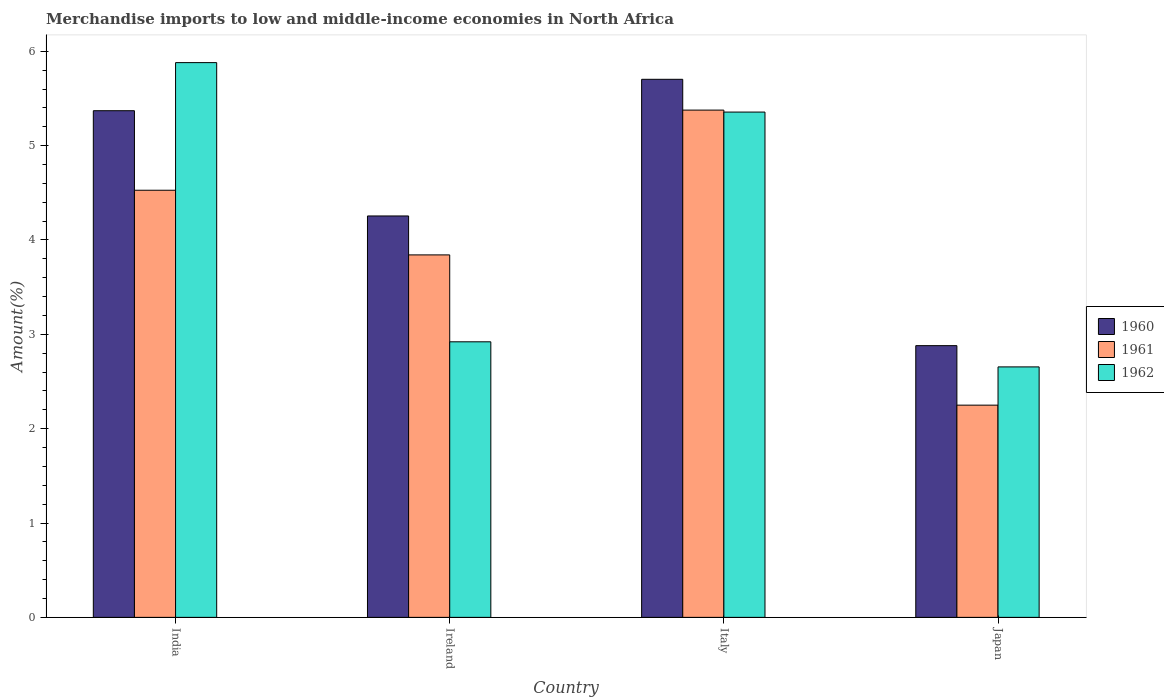Are the number of bars on each tick of the X-axis equal?
Ensure brevity in your answer.  Yes. How many bars are there on the 1st tick from the right?
Provide a succinct answer. 3. What is the percentage of amount earned from merchandise imports in 1962 in Ireland?
Ensure brevity in your answer.  2.92. Across all countries, what is the maximum percentage of amount earned from merchandise imports in 1960?
Keep it short and to the point. 5.7. Across all countries, what is the minimum percentage of amount earned from merchandise imports in 1962?
Offer a terse response. 2.65. In which country was the percentage of amount earned from merchandise imports in 1962 minimum?
Provide a short and direct response. Japan. What is the total percentage of amount earned from merchandise imports in 1961 in the graph?
Your answer should be compact. 16. What is the difference between the percentage of amount earned from merchandise imports in 1962 in Ireland and that in Japan?
Your answer should be very brief. 0.27. What is the difference between the percentage of amount earned from merchandise imports in 1961 in Italy and the percentage of amount earned from merchandise imports in 1962 in India?
Provide a short and direct response. -0.5. What is the average percentage of amount earned from merchandise imports in 1962 per country?
Provide a short and direct response. 4.2. What is the difference between the percentage of amount earned from merchandise imports of/in 1961 and percentage of amount earned from merchandise imports of/in 1960 in Japan?
Keep it short and to the point. -0.63. In how many countries, is the percentage of amount earned from merchandise imports in 1960 greater than 1.4 %?
Provide a short and direct response. 4. What is the ratio of the percentage of amount earned from merchandise imports in 1961 in Italy to that in Japan?
Your answer should be very brief. 2.39. Is the difference between the percentage of amount earned from merchandise imports in 1961 in Ireland and Italy greater than the difference between the percentage of amount earned from merchandise imports in 1960 in Ireland and Italy?
Offer a terse response. No. What is the difference between the highest and the second highest percentage of amount earned from merchandise imports in 1960?
Provide a succinct answer. 1.12. What is the difference between the highest and the lowest percentage of amount earned from merchandise imports in 1960?
Your response must be concise. 2.82. What does the 2nd bar from the left in Ireland represents?
Offer a very short reply. 1961. What does the 2nd bar from the right in Japan represents?
Offer a very short reply. 1961. Is it the case that in every country, the sum of the percentage of amount earned from merchandise imports in 1962 and percentage of amount earned from merchandise imports in 1960 is greater than the percentage of amount earned from merchandise imports in 1961?
Your answer should be very brief. Yes. How many bars are there?
Your answer should be very brief. 12. Are all the bars in the graph horizontal?
Provide a short and direct response. No. How many countries are there in the graph?
Your answer should be compact. 4. Are the values on the major ticks of Y-axis written in scientific E-notation?
Your answer should be very brief. No. Does the graph contain any zero values?
Give a very brief answer. No. Where does the legend appear in the graph?
Keep it short and to the point. Center right. How many legend labels are there?
Give a very brief answer. 3. What is the title of the graph?
Make the answer very short. Merchandise imports to low and middle-income economies in North Africa. What is the label or title of the X-axis?
Ensure brevity in your answer.  Country. What is the label or title of the Y-axis?
Offer a very short reply. Amount(%). What is the Amount(%) of 1960 in India?
Your response must be concise. 5.37. What is the Amount(%) of 1961 in India?
Your answer should be compact. 4.53. What is the Amount(%) in 1962 in India?
Your answer should be compact. 5.88. What is the Amount(%) in 1960 in Ireland?
Provide a short and direct response. 4.25. What is the Amount(%) of 1961 in Ireland?
Your answer should be compact. 3.84. What is the Amount(%) in 1962 in Ireland?
Your answer should be very brief. 2.92. What is the Amount(%) in 1960 in Italy?
Your response must be concise. 5.7. What is the Amount(%) of 1961 in Italy?
Your answer should be compact. 5.38. What is the Amount(%) in 1962 in Italy?
Give a very brief answer. 5.36. What is the Amount(%) in 1960 in Japan?
Provide a succinct answer. 2.88. What is the Amount(%) in 1961 in Japan?
Make the answer very short. 2.25. What is the Amount(%) in 1962 in Japan?
Provide a short and direct response. 2.65. Across all countries, what is the maximum Amount(%) in 1960?
Your response must be concise. 5.7. Across all countries, what is the maximum Amount(%) in 1961?
Your answer should be compact. 5.38. Across all countries, what is the maximum Amount(%) of 1962?
Give a very brief answer. 5.88. Across all countries, what is the minimum Amount(%) of 1960?
Offer a terse response. 2.88. Across all countries, what is the minimum Amount(%) of 1961?
Your answer should be very brief. 2.25. Across all countries, what is the minimum Amount(%) of 1962?
Ensure brevity in your answer.  2.65. What is the total Amount(%) in 1960 in the graph?
Make the answer very short. 18.21. What is the total Amount(%) in 1961 in the graph?
Offer a terse response. 16. What is the total Amount(%) in 1962 in the graph?
Provide a short and direct response. 16.81. What is the difference between the Amount(%) of 1960 in India and that in Ireland?
Offer a terse response. 1.12. What is the difference between the Amount(%) in 1961 in India and that in Ireland?
Give a very brief answer. 0.69. What is the difference between the Amount(%) of 1962 in India and that in Ireland?
Provide a succinct answer. 2.96. What is the difference between the Amount(%) of 1960 in India and that in Italy?
Offer a very short reply. -0.33. What is the difference between the Amount(%) of 1961 in India and that in Italy?
Offer a terse response. -0.85. What is the difference between the Amount(%) in 1962 in India and that in Italy?
Make the answer very short. 0.52. What is the difference between the Amount(%) of 1960 in India and that in Japan?
Your response must be concise. 2.49. What is the difference between the Amount(%) of 1961 in India and that in Japan?
Provide a short and direct response. 2.28. What is the difference between the Amount(%) in 1962 in India and that in Japan?
Your response must be concise. 3.23. What is the difference between the Amount(%) of 1960 in Ireland and that in Italy?
Offer a very short reply. -1.45. What is the difference between the Amount(%) of 1961 in Ireland and that in Italy?
Your answer should be very brief. -1.53. What is the difference between the Amount(%) of 1962 in Ireland and that in Italy?
Ensure brevity in your answer.  -2.44. What is the difference between the Amount(%) in 1960 in Ireland and that in Japan?
Your response must be concise. 1.37. What is the difference between the Amount(%) in 1961 in Ireland and that in Japan?
Your response must be concise. 1.59. What is the difference between the Amount(%) of 1962 in Ireland and that in Japan?
Keep it short and to the point. 0.27. What is the difference between the Amount(%) of 1960 in Italy and that in Japan?
Make the answer very short. 2.82. What is the difference between the Amount(%) of 1961 in Italy and that in Japan?
Your response must be concise. 3.13. What is the difference between the Amount(%) in 1962 in Italy and that in Japan?
Your response must be concise. 2.7. What is the difference between the Amount(%) of 1960 in India and the Amount(%) of 1961 in Ireland?
Offer a terse response. 1.53. What is the difference between the Amount(%) in 1960 in India and the Amount(%) in 1962 in Ireland?
Your response must be concise. 2.45. What is the difference between the Amount(%) in 1961 in India and the Amount(%) in 1962 in Ireland?
Your answer should be very brief. 1.61. What is the difference between the Amount(%) of 1960 in India and the Amount(%) of 1961 in Italy?
Offer a very short reply. -0.01. What is the difference between the Amount(%) in 1960 in India and the Amount(%) in 1962 in Italy?
Offer a terse response. 0.01. What is the difference between the Amount(%) of 1961 in India and the Amount(%) of 1962 in Italy?
Ensure brevity in your answer.  -0.83. What is the difference between the Amount(%) in 1960 in India and the Amount(%) in 1961 in Japan?
Your answer should be compact. 3.12. What is the difference between the Amount(%) of 1960 in India and the Amount(%) of 1962 in Japan?
Keep it short and to the point. 2.72. What is the difference between the Amount(%) in 1961 in India and the Amount(%) in 1962 in Japan?
Provide a short and direct response. 1.87. What is the difference between the Amount(%) of 1960 in Ireland and the Amount(%) of 1961 in Italy?
Your answer should be very brief. -1.12. What is the difference between the Amount(%) in 1960 in Ireland and the Amount(%) in 1962 in Italy?
Provide a short and direct response. -1.1. What is the difference between the Amount(%) of 1961 in Ireland and the Amount(%) of 1962 in Italy?
Keep it short and to the point. -1.51. What is the difference between the Amount(%) of 1960 in Ireland and the Amount(%) of 1961 in Japan?
Your answer should be compact. 2.01. What is the difference between the Amount(%) of 1960 in Ireland and the Amount(%) of 1962 in Japan?
Offer a very short reply. 1.6. What is the difference between the Amount(%) of 1961 in Ireland and the Amount(%) of 1962 in Japan?
Provide a short and direct response. 1.19. What is the difference between the Amount(%) of 1960 in Italy and the Amount(%) of 1961 in Japan?
Make the answer very short. 3.45. What is the difference between the Amount(%) in 1960 in Italy and the Amount(%) in 1962 in Japan?
Your answer should be compact. 3.05. What is the difference between the Amount(%) in 1961 in Italy and the Amount(%) in 1962 in Japan?
Offer a terse response. 2.72. What is the average Amount(%) in 1960 per country?
Keep it short and to the point. 4.55. What is the average Amount(%) of 1961 per country?
Offer a very short reply. 4. What is the average Amount(%) of 1962 per country?
Provide a succinct answer. 4.2. What is the difference between the Amount(%) of 1960 and Amount(%) of 1961 in India?
Your answer should be compact. 0.84. What is the difference between the Amount(%) in 1960 and Amount(%) in 1962 in India?
Your answer should be very brief. -0.51. What is the difference between the Amount(%) of 1961 and Amount(%) of 1962 in India?
Ensure brevity in your answer.  -1.35. What is the difference between the Amount(%) of 1960 and Amount(%) of 1961 in Ireland?
Keep it short and to the point. 0.41. What is the difference between the Amount(%) of 1960 and Amount(%) of 1962 in Ireland?
Give a very brief answer. 1.33. What is the difference between the Amount(%) of 1961 and Amount(%) of 1962 in Ireland?
Your answer should be compact. 0.92. What is the difference between the Amount(%) in 1960 and Amount(%) in 1961 in Italy?
Offer a very short reply. 0.33. What is the difference between the Amount(%) of 1960 and Amount(%) of 1962 in Italy?
Your answer should be very brief. 0.35. What is the difference between the Amount(%) in 1961 and Amount(%) in 1962 in Italy?
Provide a short and direct response. 0.02. What is the difference between the Amount(%) of 1960 and Amount(%) of 1961 in Japan?
Offer a very short reply. 0.63. What is the difference between the Amount(%) in 1960 and Amount(%) in 1962 in Japan?
Offer a very short reply. 0.23. What is the difference between the Amount(%) of 1961 and Amount(%) of 1962 in Japan?
Give a very brief answer. -0.41. What is the ratio of the Amount(%) in 1960 in India to that in Ireland?
Offer a very short reply. 1.26. What is the ratio of the Amount(%) of 1961 in India to that in Ireland?
Offer a terse response. 1.18. What is the ratio of the Amount(%) of 1962 in India to that in Ireland?
Offer a very short reply. 2.01. What is the ratio of the Amount(%) of 1960 in India to that in Italy?
Your answer should be very brief. 0.94. What is the ratio of the Amount(%) in 1961 in India to that in Italy?
Ensure brevity in your answer.  0.84. What is the ratio of the Amount(%) in 1962 in India to that in Italy?
Make the answer very short. 1.1. What is the ratio of the Amount(%) of 1960 in India to that in Japan?
Offer a terse response. 1.86. What is the ratio of the Amount(%) in 1961 in India to that in Japan?
Ensure brevity in your answer.  2.01. What is the ratio of the Amount(%) in 1962 in India to that in Japan?
Offer a terse response. 2.21. What is the ratio of the Amount(%) of 1960 in Ireland to that in Italy?
Offer a very short reply. 0.75. What is the ratio of the Amount(%) in 1961 in Ireland to that in Italy?
Offer a terse response. 0.71. What is the ratio of the Amount(%) of 1962 in Ireland to that in Italy?
Offer a very short reply. 0.55. What is the ratio of the Amount(%) of 1960 in Ireland to that in Japan?
Provide a short and direct response. 1.48. What is the ratio of the Amount(%) in 1961 in Ireland to that in Japan?
Your response must be concise. 1.71. What is the ratio of the Amount(%) in 1962 in Ireland to that in Japan?
Keep it short and to the point. 1.1. What is the ratio of the Amount(%) in 1960 in Italy to that in Japan?
Your response must be concise. 1.98. What is the ratio of the Amount(%) in 1961 in Italy to that in Japan?
Your response must be concise. 2.39. What is the ratio of the Amount(%) of 1962 in Italy to that in Japan?
Offer a very short reply. 2.02. What is the difference between the highest and the second highest Amount(%) in 1960?
Make the answer very short. 0.33. What is the difference between the highest and the second highest Amount(%) in 1961?
Ensure brevity in your answer.  0.85. What is the difference between the highest and the second highest Amount(%) of 1962?
Provide a succinct answer. 0.52. What is the difference between the highest and the lowest Amount(%) in 1960?
Your answer should be compact. 2.82. What is the difference between the highest and the lowest Amount(%) of 1961?
Offer a very short reply. 3.13. What is the difference between the highest and the lowest Amount(%) of 1962?
Provide a succinct answer. 3.23. 